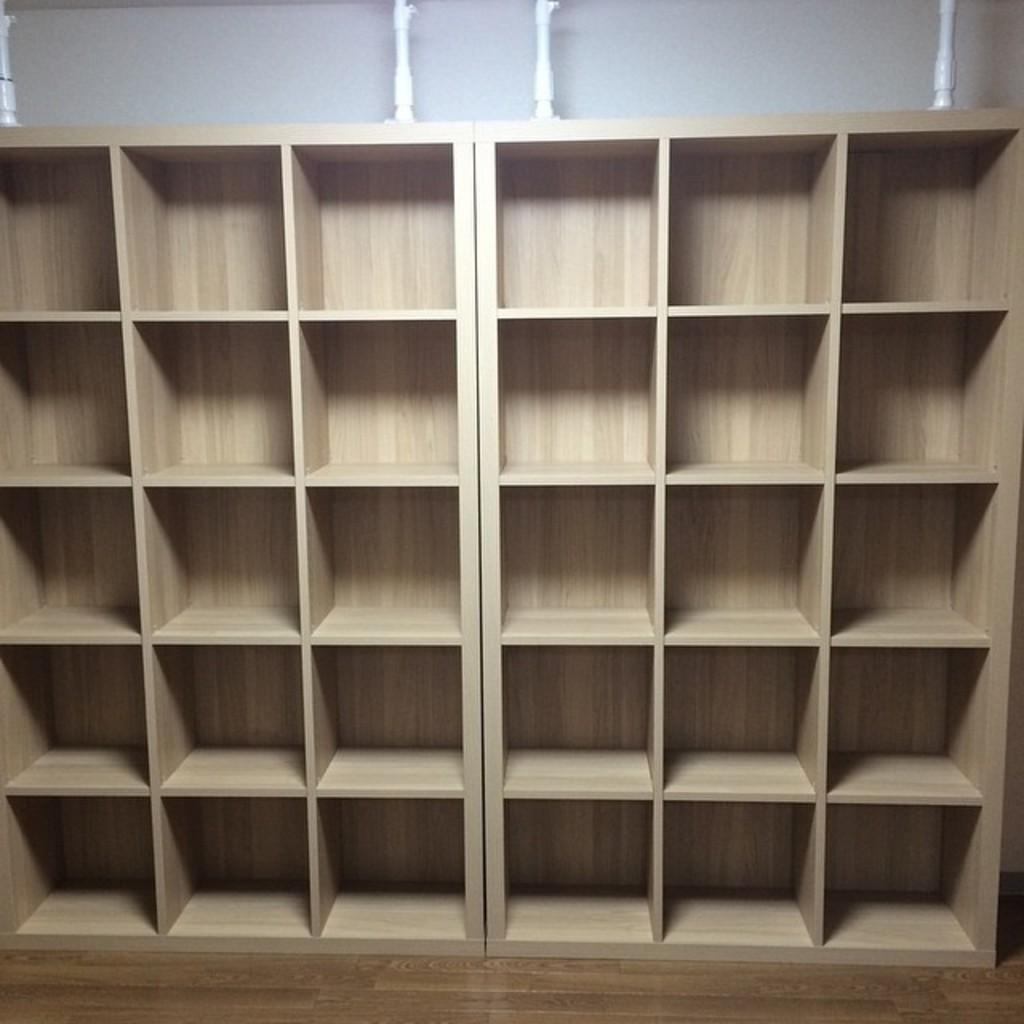What type of furniture is present in the image? There are wooden shelves in the image. What can be seen on top of the wooden shelves? There are white objects on top of the shelves. How do the dogs feel about the way the white objects are arranged on the shelves? There are no dogs present in the image, so it is not possible to determine their feelings about the arrangement of the white objects on the shelves. 